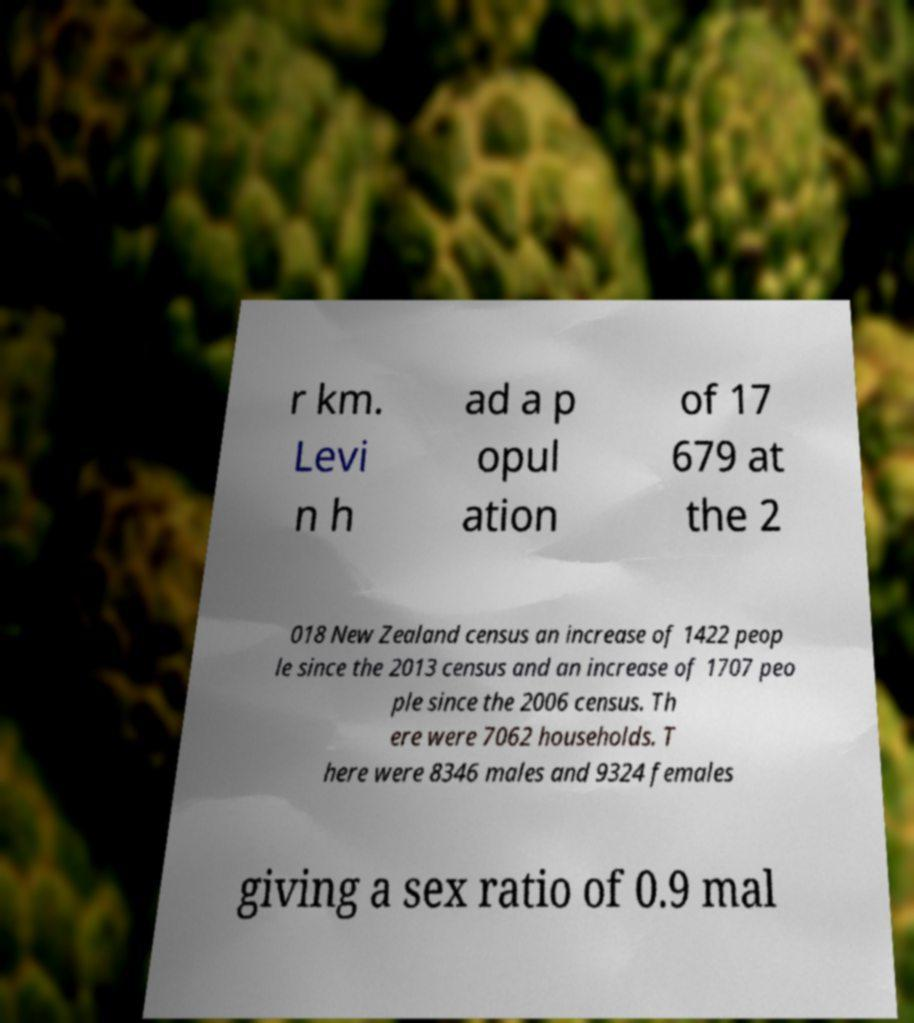There's text embedded in this image that I need extracted. Can you transcribe it verbatim? r km. Levi n h ad a p opul ation of 17 679 at the 2 018 New Zealand census an increase of 1422 peop le since the 2013 census and an increase of 1707 peo ple since the 2006 census. Th ere were 7062 households. T here were 8346 males and 9324 females giving a sex ratio of 0.9 mal 